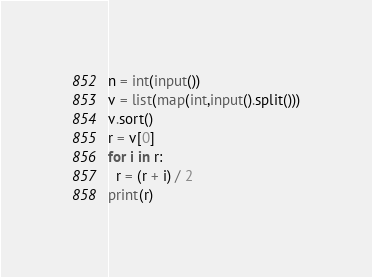<code> <loc_0><loc_0><loc_500><loc_500><_Python_>n = int(input())
v = list(map(int,input().split()))
v.sort()
r = v[0]
for i in r:
  r = (r + i) / 2
print(r)</code> 